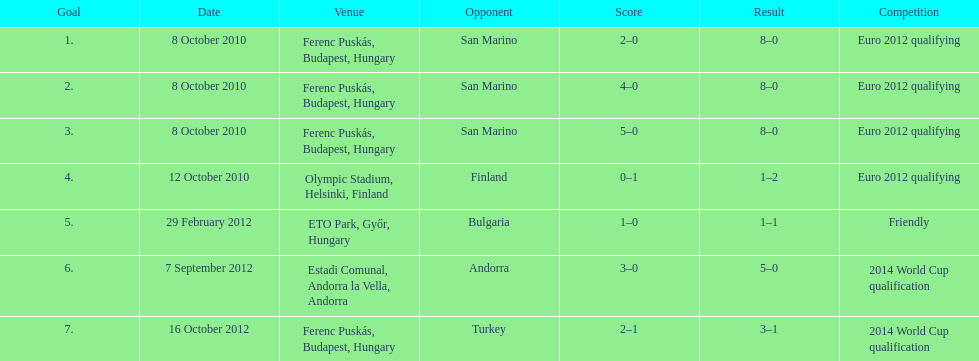What was the total number of goals scored during the euro 2012 qualifying matches? 12. 